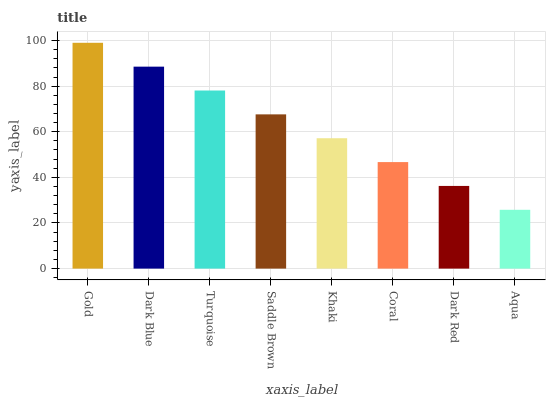Is Dark Blue the minimum?
Answer yes or no. No. Is Dark Blue the maximum?
Answer yes or no. No. Is Gold greater than Dark Blue?
Answer yes or no. Yes. Is Dark Blue less than Gold?
Answer yes or no. Yes. Is Dark Blue greater than Gold?
Answer yes or no. No. Is Gold less than Dark Blue?
Answer yes or no. No. Is Saddle Brown the high median?
Answer yes or no. Yes. Is Khaki the low median?
Answer yes or no. Yes. Is Turquoise the high median?
Answer yes or no. No. Is Dark Blue the low median?
Answer yes or no. No. 